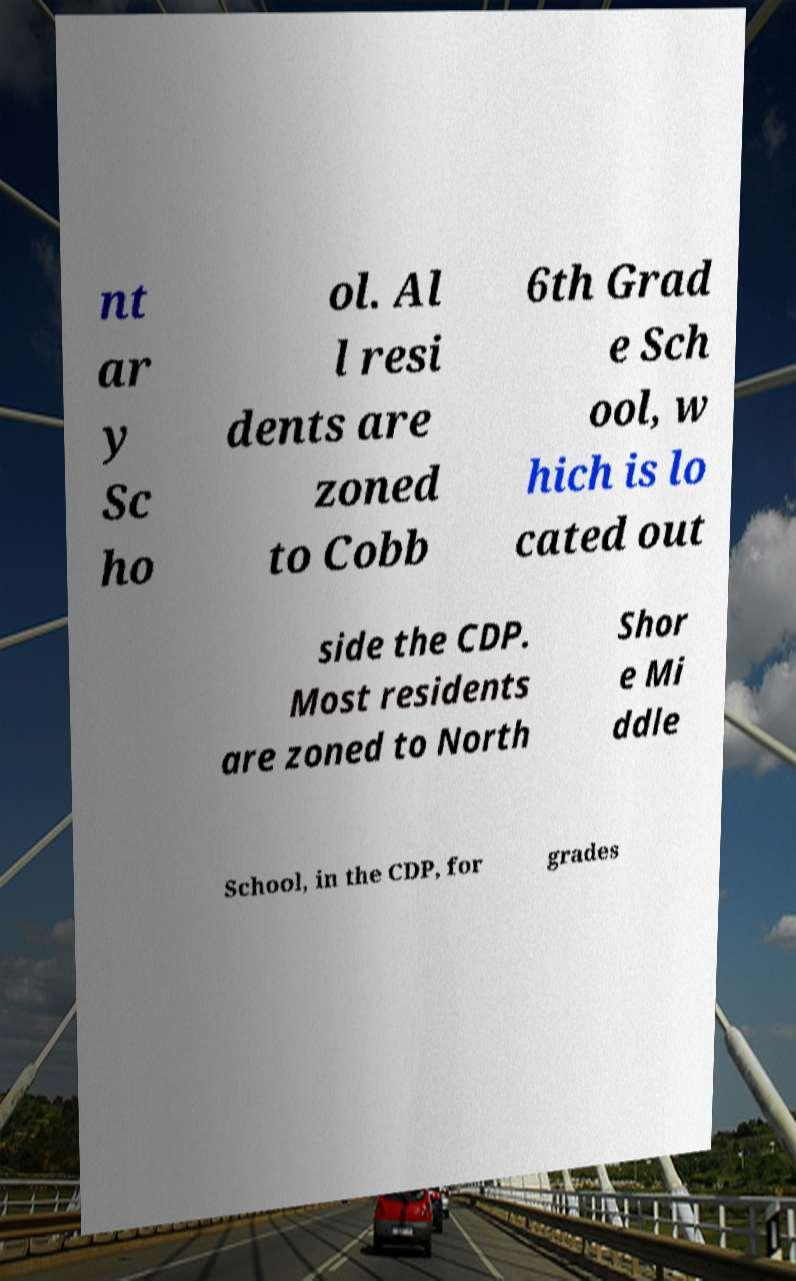For documentation purposes, I need the text within this image transcribed. Could you provide that? nt ar y Sc ho ol. Al l resi dents are zoned to Cobb 6th Grad e Sch ool, w hich is lo cated out side the CDP. Most residents are zoned to North Shor e Mi ddle School, in the CDP, for grades 